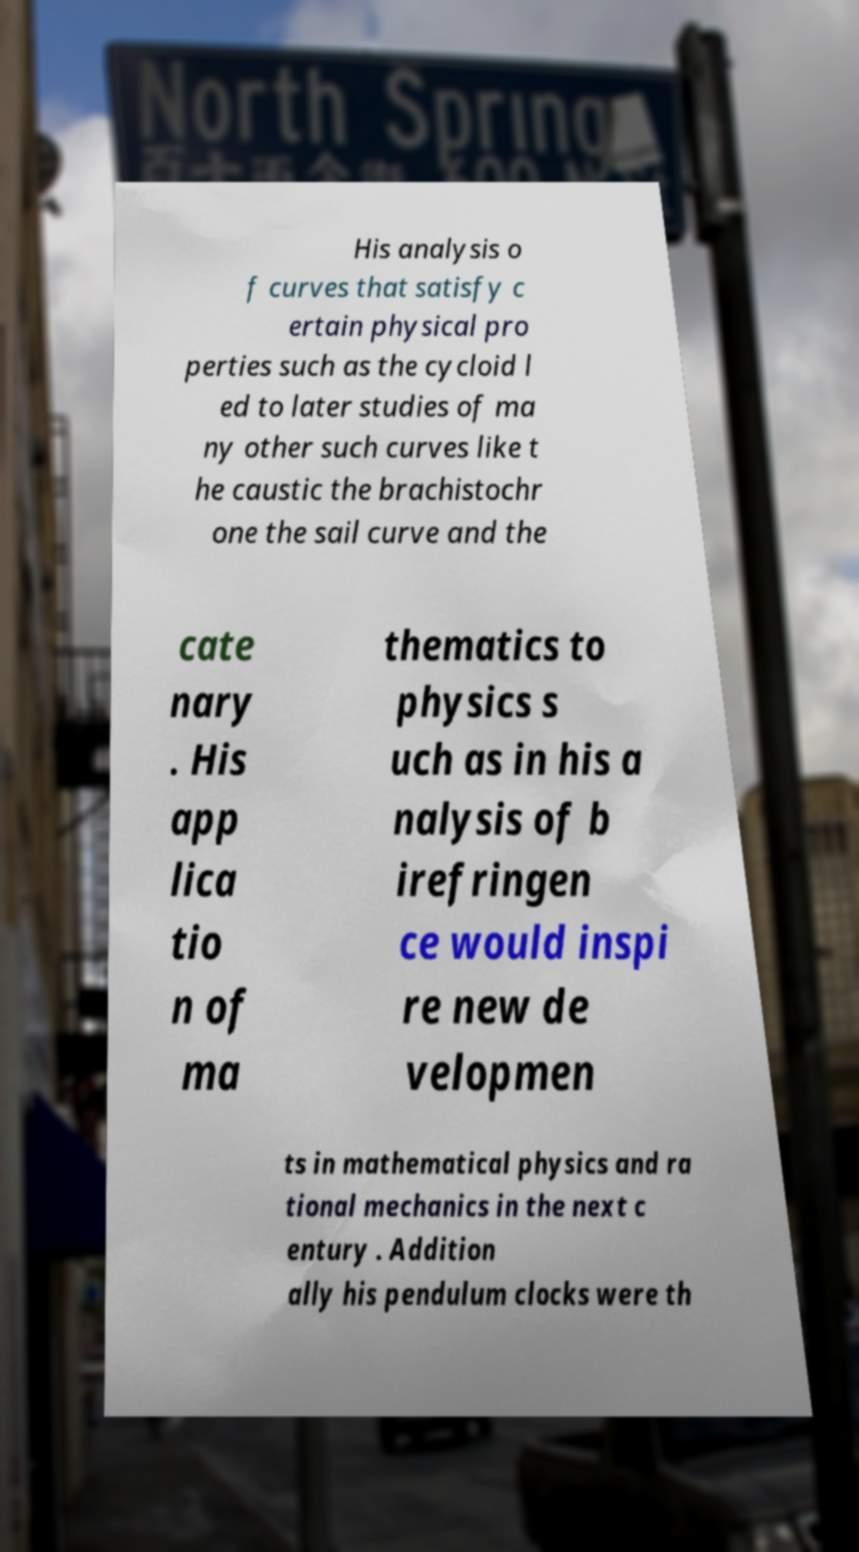Please identify and transcribe the text found in this image. His analysis o f curves that satisfy c ertain physical pro perties such as the cycloid l ed to later studies of ma ny other such curves like t he caustic the brachistochr one the sail curve and the cate nary . His app lica tio n of ma thematics to physics s uch as in his a nalysis of b irefringen ce would inspi re new de velopmen ts in mathematical physics and ra tional mechanics in the next c entury . Addition ally his pendulum clocks were th 